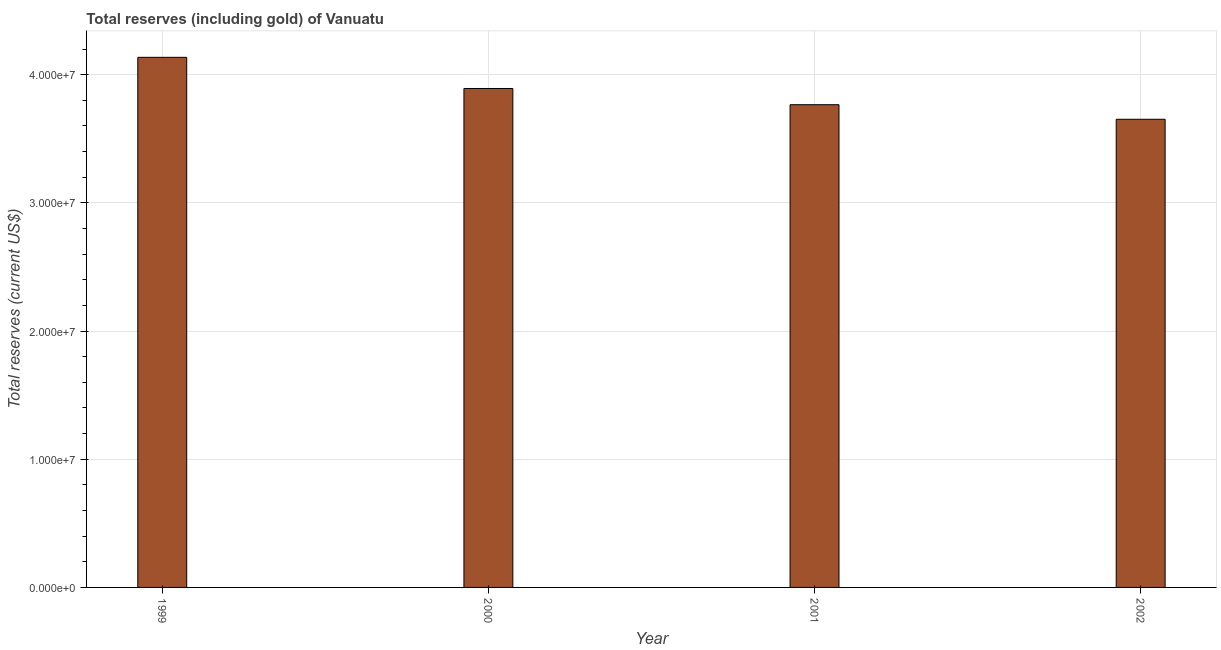Does the graph contain any zero values?
Your response must be concise. No. Does the graph contain grids?
Make the answer very short. Yes. What is the title of the graph?
Provide a succinct answer. Total reserves (including gold) of Vanuatu. What is the label or title of the X-axis?
Offer a terse response. Year. What is the label or title of the Y-axis?
Ensure brevity in your answer.  Total reserves (current US$). What is the total reserves (including gold) in 1999?
Provide a succinct answer. 4.14e+07. Across all years, what is the maximum total reserves (including gold)?
Your answer should be very brief. 4.14e+07. Across all years, what is the minimum total reserves (including gold)?
Provide a short and direct response. 3.65e+07. What is the sum of the total reserves (including gold)?
Give a very brief answer. 1.54e+08. What is the difference between the total reserves (including gold) in 2000 and 2001?
Your answer should be compact. 1.26e+06. What is the average total reserves (including gold) per year?
Offer a terse response. 3.86e+07. What is the median total reserves (including gold)?
Provide a succinct answer. 3.83e+07. In how many years, is the total reserves (including gold) greater than 28000000 US$?
Make the answer very short. 4. Do a majority of the years between 2002 and 2000 (inclusive) have total reserves (including gold) greater than 2000000 US$?
Ensure brevity in your answer.  Yes. What is the ratio of the total reserves (including gold) in 1999 to that in 2001?
Your answer should be very brief. 1.1. Is the difference between the total reserves (including gold) in 2000 and 2002 greater than the difference between any two years?
Your answer should be compact. No. What is the difference between the highest and the second highest total reserves (including gold)?
Offer a very short reply. 2.43e+06. What is the difference between the highest and the lowest total reserves (including gold)?
Your response must be concise. 4.83e+06. In how many years, is the total reserves (including gold) greater than the average total reserves (including gold) taken over all years?
Keep it short and to the point. 2. How many years are there in the graph?
Offer a terse response. 4. What is the difference between two consecutive major ticks on the Y-axis?
Offer a terse response. 1.00e+07. What is the Total reserves (current US$) of 1999?
Offer a terse response. 4.14e+07. What is the Total reserves (current US$) of 2000?
Offer a terse response. 3.89e+07. What is the Total reserves (current US$) of 2001?
Your answer should be compact. 3.77e+07. What is the Total reserves (current US$) in 2002?
Offer a very short reply. 3.65e+07. What is the difference between the Total reserves (current US$) in 1999 and 2000?
Provide a short and direct response. 2.43e+06. What is the difference between the Total reserves (current US$) in 1999 and 2001?
Your answer should be compact. 3.70e+06. What is the difference between the Total reserves (current US$) in 1999 and 2002?
Provide a short and direct response. 4.83e+06. What is the difference between the Total reserves (current US$) in 2000 and 2001?
Offer a very short reply. 1.26e+06. What is the difference between the Total reserves (current US$) in 2000 and 2002?
Offer a terse response. 2.40e+06. What is the difference between the Total reserves (current US$) in 2001 and 2002?
Your answer should be compact. 1.14e+06. What is the ratio of the Total reserves (current US$) in 1999 to that in 2000?
Ensure brevity in your answer.  1.06. What is the ratio of the Total reserves (current US$) in 1999 to that in 2001?
Provide a short and direct response. 1.1. What is the ratio of the Total reserves (current US$) in 1999 to that in 2002?
Your response must be concise. 1.13. What is the ratio of the Total reserves (current US$) in 2000 to that in 2001?
Your response must be concise. 1.03. What is the ratio of the Total reserves (current US$) in 2000 to that in 2002?
Your answer should be compact. 1.07. What is the ratio of the Total reserves (current US$) in 2001 to that in 2002?
Offer a terse response. 1.03. 